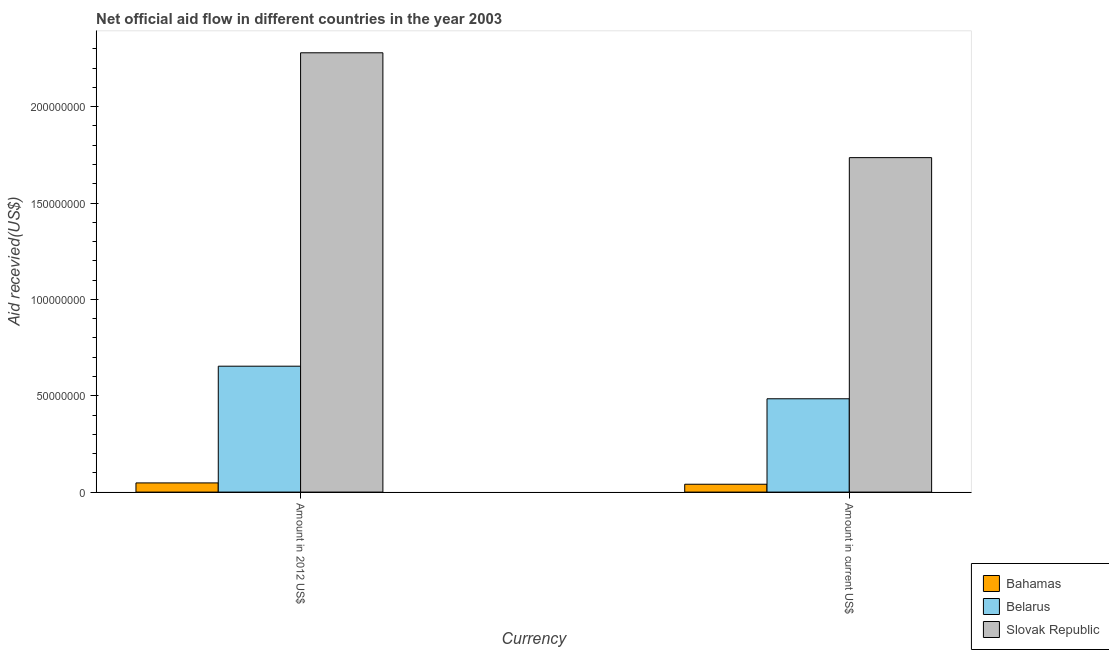How many different coloured bars are there?
Your answer should be very brief. 3. Are the number of bars per tick equal to the number of legend labels?
Give a very brief answer. Yes. Are the number of bars on each tick of the X-axis equal?
Your answer should be compact. Yes. How many bars are there on the 1st tick from the left?
Offer a very short reply. 3. What is the label of the 1st group of bars from the left?
Your answer should be compact. Amount in 2012 US$. What is the amount of aid received(expressed in 2012 us$) in Slovak Republic?
Make the answer very short. 2.28e+08. Across all countries, what is the maximum amount of aid received(expressed in us$)?
Give a very brief answer. 1.74e+08. Across all countries, what is the minimum amount of aid received(expressed in us$)?
Provide a succinct answer. 4.07e+06. In which country was the amount of aid received(expressed in us$) maximum?
Ensure brevity in your answer.  Slovak Republic. In which country was the amount of aid received(expressed in us$) minimum?
Your response must be concise. Bahamas. What is the total amount of aid received(expressed in us$) in the graph?
Provide a succinct answer. 2.26e+08. What is the difference between the amount of aid received(expressed in 2012 us$) in Bahamas and that in Slovak Republic?
Provide a succinct answer. -2.23e+08. What is the difference between the amount of aid received(expressed in us$) in Slovak Republic and the amount of aid received(expressed in 2012 us$) in Bahamas?
Offer a very short reply. 1.69e+08. What is the average amount of aid received(expressed in us$) per country?
Offer a very short reply. 7.54e+07. What is the difference between the amount of aid received(expressed in us$) and amount of aid received(expressed in 2012 us$) in Belarus?
Give a very brief answer. -1.69e+07. What is the ratio of the amount of aid received(expressed in 2012 us$) in Slovak Republic to that in Bahamas?
Your answer should be very brief. 47.89. What does the 3rd bar from the left in Amount in 2012 US$ represents?
Give a very brief answer. Slovak Republic. What does the 1st bar from the right in Amount in current US$ represents?
Ensure brevity in your answer.  Slovak Republic. How many countries are there in the graph?
Make the answer very short. 3. What is the difference between two consecutive major ticks on the Y-axis?
Provide a short and direct response. 5.00e+07. Are the values on the major ticks of Y-axis written in scientific E-notation?
Ensure brevity in your answer.  No. Does the graph contain any zero values?
Your response must be concise. No. Where does the legend appear in the graph?
Ensure brevity in your answer.  Bottom right. What is the title of the graph?
Your answer should be compact. Net official aid flow in different countries in the year 2003. Does "Kazakhstan" appear as one of the legend labels in the graph?
Offer a very short reply. No. What is the label or title of the X-axis?
Offer a very short reply. Currency. What is the label or title of the Y-axis?
Keep it short and to the point. Aid recevied(US$). What is the Aid recevied(US$) in Bahamas in Amount in 2012 US$?
Your answer should be compact. 4.76e+06. What is the Aid recevied(US$) in Belarus in Amount in 2012 US$?
Give a very brief answer. 6.53e+07. What is the Aid recevied(US$) of Slovak Republic in Amount in 2012 US$?
Offer a terse response. 2.28e+08. What is the Aid recevied(US$) of Bahamas in Amount in current US$?
Offer a very short reply. 4.07e+06. What is the Aid recevied(US$) of Belarus in Amount in current US$?
Give a very brief answer. 4.84e+07. What is the Aid recevied(US$) of Slovak Republic in Amount in current US$?
Provide a succinct answer. 1.74e+08. Across all Currency, what is the maximum Aid recevied(US$) of Bahamas?
Offer a terse response. 4.76e+06. Across all Currency, what is the maximum Aid recevied(US$) in Belarus?
Give a very brief answer. 6.53e+07. Across all Currency, what is the maximum Aid recevied(US$) of Slovak Republic?
Provide a short and direct response. 2.28e+08. Across all Currency, what is the minimum Aid recevied(US$) in Bahamas?
Your answer should be compact. 4.07e+06. Across all Currency, what is the minimum Aid recevied(US$) of Belarus?
Keep it short and to the point. 4.84e+07. Across all Currency, what is the minimum Aid recevied(US$) of Slovak Republic?
Provide a short and direct response. 1.74e+08. What is the total Aid recevied(US$) of Bahamas in the graph?
Your answer should be compact. 8.83e+06. What is the total Aid recevied(US$) in Belarus in the graph?
Keep it short and to the point. 1.14e+08. What is the total Aid recevied(US$) in Slovak Republic in the graph?
Offer a very short reply. 4.02e+08. What is the difference between the Aid recevied(US$) in Bahamas in Amount in 2012 US$ and that in Amount in current US$?
Your response must be concise. 6.90e+05. What is the difference between the Aid recevied(US$) in Belarus in Amount in 2012 US$ and that in Amount in current US$?
Give a very brief answer. 1.69e+07. What is the difference between the Aid recevied(US$) in Slovak Republic in Amount in 2012 US$ and that in Amount in current US$?
Offer a terse response. 5.44e+07. What is the difference between the Aid recevied(US$) in Bahamas in Amount in 2012 US$ and the Aid recevied(US$) in Belarus in Amount in current US$?
Give a very brief answer. -4.37e+07. What is the difference between the Aid recevied(US$) of Bahamas in Amount in 2012 US$ and the Aid recevied(US$) of Slovak Republic in Amount in current US$?
Keep it short and to the point. -1.69e+08. What is the difference between the Aid recevied(US$) of Belarus in Amount in 2012 US$ and the Aid recevied(US$) of Slovak Republic in Amount in current US$?
Your answer should be compact. -1.08e+08. What is the average Aid recevied(US$) in Bahamas per Currency?
Offer a very short reply. 4.42e+06. What is the average Aid recevied(US$) in Belarus per Currency?
Your answer should be very brief. 5.69e+07. What is the average Aid recevied(US$) of Slovak Republic per Currency?
Give a very brief answer. 2.01e+08. What is the difference between the Aid recevied(US$) of Bahamas and Aid recevied(US$) of Belarus in Amount in 2012 US$?
Offer a very short reply. -6.06e+07. What is the difference between the Aid recevied(US$) in Bahamas and Aid recevied(US$) in Slovak Republic in Amount in 2012 US$?
Ensure brevity in your answer.  -2.23e+08. What is the difference between the Aid recevied(US$) of Belarus and Aid recevied(US$) of Slovak Republic in Amount in 2012 US$?
Your response must be concise. -1.63e+08. What is the difference between the Aid recevied(US$) of Bahamas and Aid recevied(US$) of Belarus in Amount in current US$?
Your answer should be compact. -4.44e+07. What is the difference between the Aid recevied(US$) in Bahamas and Aid recevied(US$) in Slovak Republic in Amount in current US$?
Your answer should be very brief. -1.70e+08. What is the difference between the Aid recevied(US$) in Belarus and Aid recevied(US$) in Slovak Republic in Amount in current US$?
Keep it short and to the point. -1.25e+08. What is the ratio of the Aid recevied(US$) of Bahamas in Amount in 2012 US$ to that in Amount in current US$?
Keep it short and to the point. 1.17. What is the ratio of the Aid recevied(US$) in Belarus in Amount in 2012 US$ to that in Amount in current US$?
Give a very brief answer. 1.35. What is the ratio of the Aid recevied(US$) in Slovak Republic in Amount in 2012 US$ to that in Amount in current US$?
Provide a short and direct response. 1.31. What is the difference between the highest and the second highest Aid recevied(US$) of Bahamas?
Give a very brief answer. 6.90e+05. What is the difference between the highest and the second highest Aid recevied(US$) of Belarus?
Offer a terse response. 1.69e+07. What is the difference between the highest and the second highest Aid recevied(US$) in Slovak Republic?
Provide a succinct answer. 5.44e+07. What is the difference between the highest and the lowest Aid recevied(US$) of Bahamas?
Provide a succinct answer. 6.90e+05. What is the difference between the highest and the lowest Aid recevied(US$) of Belarus?
Provide a short and direct response. 1.69e+07. What is the difference between the highest and the lowest Aid recevied(US$) in Slovak Republic?
Offer a very short reply. 5.44e+07. 